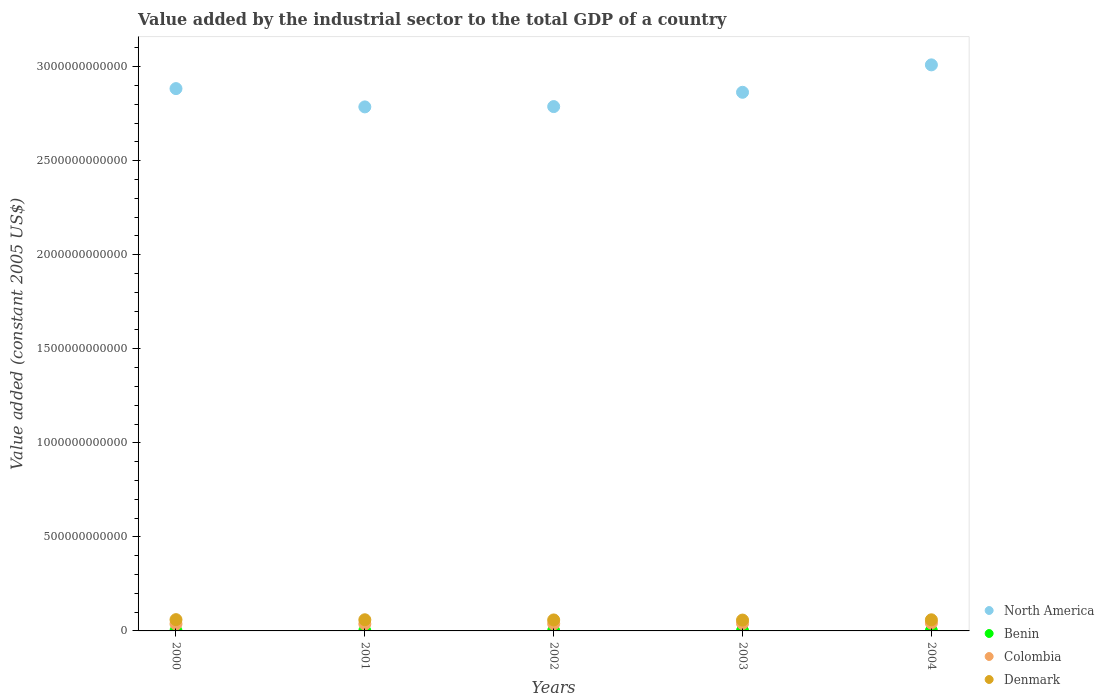How many different coloured dotlines are there?
Offer a very short reply. 4. Is the number of dotlines equal to the number of legend labels?
Offer a very short reply. Yes. What is the value added by the industrial sector in Colombia in 2002?
Keep it short and to the point. 3.79e+1. Across all years, what is the maximum value added by the industrial sector in Colombia?
Make the answer very short. 4.20e+1. Across all years, what is the minimum value added by the industrial sector in Colombia?
Make the answer very short. 3.68e+1. In which year was the value added by the industrial sector in Colombia maximum?
Provide a short and direct response. 2004. In which year was the value added by the industrial sector in Colombia minimum?
Your answer should be very brief. 2000. What is the total value added by the industrial sector in Colombia in the graph?
Provide a succinct answer. 1.93e+11. What is the difference between the value added by the industrial sector in Denmark in 2000 and that in 2002?
Offer a terse response. 1.55e+09. What is the difference between the value added by the industrial sector in North America in 2002 and the value added by the industrial sector in Denmark in 2003?
Make the answer very short. 2.73e+12. What is the average value added by the industrial sector in North America per year?
Provide a short and direct response. 2.87e+12. In the year 2002, what is the difference between the value added by the industrial sector in North America and value added by the industrial sector in Colombia?
Offer a terse response. 2.75e+12. In how many years, is the value added by the industrial sector in Denmark greater than 1900000000000 US$?
Keep it short and to the point. 0. What is the ratio of the value added by the industrial sector in North America in 2000 to that in 2001?
Offer a very short reply. 1.03. Is the difference between the value added by the industrial sector in North America in 2000 and 2004 greater than the difference between the value added by the industrial sector in Colombia in 2000 and 2004?
Provide a short and direct response. No. What is the difference between the highest and the second highest value added by the industrial sector in Colombia?
Provide a short and direct response. 2.31e+09. What is the difference between the highest and the lowest value added by the industrial sector in Colombia?
Your answer should be very brief. 5.16e+09. In how many years, is the value added by the industrial sector in Colombia greater than the average value added by the industrial sector in Colombia taken over all years?
Your response must be concise. 2. Is it the case that in every year, the sum of the value added by the industrial sector in North America and value added by the industrial sector in Denmark  is greater than the sum of value added by the industrial sector in Colombia and value added by the industrial sector in Benin?
Your answer should be compact. Yes. Is it the case that in every year, the sum of the value added by the industrial sector in Denmark and value added by the industrial sector in North America  is greater than the value added by the industrial sector in Benin?
Your answer should be compact. Yes. How many years are there in the graph?
Give a very brief answer. 5. What is the difference between two consecutive major ticks on the Y-axis?
Give a very brief answer. 5.00e+11. Where does the legend appear in the graph?
Offer a terse response. Bottom right. How many legend labels are there?
Offer a very short reply. 4. What is the title of the graph?
Offer a terse response. Value added by the industrial sector to the total GDP of a country. What is the label or title of the X-axis?
Your answer should be very brief. Years. What is the label or title of the Y-axis?
Your answer should be very brief. Value added (constant 2005 US$). What is the Value added (constant 2005 US$) in North America in 2000?
Offer a terse response. 2.88e+12. What is the Value added (constant 2005 US$) of Benin in 2000?
Your answer should be very brief. 1.16e+09. What is the Value added (constant 2005 US$) of Colombia in 2000?
Provide a succinct answer. 3.68e+1. What is the Value added (constant 2005 US$) of Denmark in 2000?
Ensure brevity in your answer.  5.99e+1. What is the Value added (constant 2005 US$) of North America in 2001?
Keep it short and to the point. 2.79e+12. What is the Value added (constant 2005 US$) of Benin in 2001?
Ensure brevity in your answer.  1.24e+09. What is the Value added (constant 2005 US$) in Colombia in 2001?
Your response must be concise. 3.69e+1. What is the Value added (constant 2005 US$) in Denmark in 2001?
Provide a succinct answer. 5.93e+1. What is the Value added (constant 2005 US$) of North America in 2002?
Offer a terse response. 2.79e+12. What is the Value added (constant 2005 US$) of Benin in 2002?
Keep it short and to the point. 1.25e+09. What is the Value added (constant 2005 US$) of Colombia in 2002?
Your response must be concise. 3.79e+1. What is the Value added (constant 2005 US$) of Denmark in 2002?
Make the answer very short. 5.84e+1. What is the Value added (constant 2005 US$) in North America in 2003?
Your answer should be compact. 2.86e+12. What is the Value added (constant 2005 US$) of Benin in 2003?
Offer a terse response. 1.25e+09. What is the Value added (constant 2005 US$) in Colombia in 2003?
Your response must be concise. 3.97e+1. What is the Value added (constant 2005 US$) in Denmark in 2003?
Offer a terse response. 5.77e+1. What is the Value added (constant 2005 US$) in North America in 2004?
Offer a very short reply. 3.01e+12. What is the Value added (constant 2005 US$) of Benin in 2004?
Ensure brevity in your answer.  1.27e+09. What is the Value added (constant 2005 US$) of Colombia in 2004?
Provide a succinct answer. 4.20e+1. What is the Value added (constant 2005 US$) in Denmark in 2004?
Offer a terse response. 5.91e+1. Across all years, what is the maximum Value added (constant 2005 US$) in North America?
Provide a succinct answer. 3.01e+12. Across all years, what is the maximum Value added (constant 2005 US$) of Benin?
Offer a terse response. 1.27e+09. Across all years, what is the maximum Value added (constant 2005 US$) of Colombia?
Your answer should be very brief. 4.20e+1. Across all years, what is the maximum Value added (constant 2005 US$) in Denmark?
Provide a short and direct response. 5.99e+1. Across all years, what is the minimum Value added (constant 2005 US$) of North America?
Provide a short and direct response. 2.79e+12. Across all years, what is the minimum Value added (constant 2005 US$) of Benin?
Your answer should be very brief. 1.16e+09. Across all years, what is the minimum Value added (constant 2005 US$) of Colombia?
Offer a very short reply. 3.68e+1. Across all years, what is the minimum Value added (constant 2005 US$) in Denmark?
Ensure brevity in your answer.  5.77e+1. What is the total Value added (constant 2005 US$) of North America in the graph?
Your answer should be very brief. 1.43e+13. What is the total Value added (constant 2005 US$) of Benin in the graph?
Your answer should be very brief. 6.17e+09. What is the total Value added (constant 2005 US$) in Colombia in the graph?
Provide a succinct answer. 1.93e+11. What is the total Value added (constant 2005 US$) in Denmark in the graph?
Offer a very short reply. 2.94e+11. What is the difference between the Value added (constant 2005 US$) of North America in 2000 and that in 2001?
Offer a very short reply. 9.72e+1. What is the difference between the Value added (constant 2005 US$) of Benin in 2000 and that in 2001?
Your response must be concise. -7.88e+07. What is the difference between the Value added (constant 2005 US$) in Colombia in 2000 and that in 2001?
Provide a succinct answer. -1.35e+08. What is the difference between the Value added (constant 2005 US$) in Denmark in 2000 and that in 2001?
Ensure brevity in your answer.  6.13e+08. What is the difference between the Value added (constant 2005 US$) of North America in 2000 and that in 2002?
Ensure brevity in your answer.  9.56e+1. What is the difference between the Value added (constant 2005 US$) in Benin in 2000 and that in 2002?
Give a very brief answer. -8.92e+07. What is the difference between the Value added (constant 2005 US$) in Colombia in 2000 and that in 2002?
Offer a terse response. -1.08e+09. What is the difference between the Value added (constant 2005 US$) of Denmark in 2000 and that in 2002?
Provide a short and direct response. 1.55e+09. What is the difference between the Value added (constant 2005 US$) in North America in 2000 and that in 2003?
Provide a short and direct response. 1.95e+1. What is the difference between the Value added (constant 2005 US$) in Benin in 2000 and that in 2003?
Keep it short and to the point. -8.47e+07. What is the difference between the Value added (constant 2005 US$) in Colombia in 2000 and that in 2003?
Make the answer very short. -2.86e+09. What is the difference between the Value added (constant 2005 US$) in Denmark in 2000 and that in 2003?
Your answer should be very brief. 2.24e+09. What is the difference between the Value added (constant 2005 US$) of North America in 2000 and that in 2004?
Your answer should be very brief. -1.26e+11. What is the difference between the Value added (constant 2005 US$) in Benin in 2000 and that in 2004?
Provide a short and direct response. -1.03e+08. What is the difference between the Value added (constant 2005 US$) of Colombia in 2000 and that in 2004?
Make the answer very short. -5.16e+09. What is the difference between the Value added (constant 2005 US$) of Denmark in 2000 and that in 2004?
Provide a short and direct response. 8.18e+08. What is the difference between the Value added (constant 2005 US$) in North America in 2001 and that in 2002?
Offer a terse response. -1.61e+09. What is the difference between the Value added (constant 2005 US$) in Benin in 2001 and that in 2002?
Offer a very short reply. -1.04e+07. What is the difference between the Value added (constant 2005 US$) of Colombia in 2001 and that in 2002?
Give a very brief answer. -9.49e+08. What is the difference between the Value added (constant 2005 US$) of Denmark in 2001 and that in 2002?
Provide a short and direct response. 9.36e+08. What is the difference between the Value added (constant 2005 US$) of North America in 2001 and that in 2003?
Ensure brevity in your answer.  -7.77e+1. What is the difference between the Value added (constant 2005 US$) of Benin in 2001 and that in 2003?
Ensure brevity in your answer.  -5.88e+06. What is the difference between the Value added (constant 2005 US$) in Colombia in 2001 and that in 2003?
Give a very brief answer. -2.72e+09. What is the difference between the Value added (constant 2005 US$) in Denmark in 2001 and that in 2003?
Make the answer very short. 1.63e+09. What is the difference between the Value added (constant 2005 US$) in North America in 2001 and that in 2004?
Make the answer very short. -2.23e+11. What is the difference between the Value added (constant 2005 US$) of Benin in 2001 and that in 2004?
Provide a short and direct response. -2.47e+07. What is the difference between the Value added (constant 2005 US$) of Colombia in 2001 and that in 2004?
Keep it short and to the point. -5.03e+09. What is the difference between the Value added (constant 2005 US$) in Denmark in 2001 and that in 2004?
Give a very brief answer. 2.05e+08. What is the difference between the Value added (constant 2005 US$) of North America in 2002 and that in 2003?
Your answer should be very brief. -7.61e+1. What is the difference between the Value added (constant 2005 US$) in Benin in 2002 and that in 2003?
Offer a terse response. 4.56e+06. What is the difference between the Value added (constant 2005 US$) of Colombia in 2002 and that in 2003?
Give a very brief answer. -1.77e+09. What is the difference between the Value added (constant 2005 US$) of Denmark in 2002 and that in 2003?
Your answer should be compact. 6.90e+08. What is the difference between the Value added (constant 2005 US$) in North America in 2002 and that in 2004?
Provide a short and direct response. -2.22e+11. What is the difference between the Value added (constant 2005 US$) of Benin in 2002 and that in 2004?
Your response must be concise. -1.42e+07. What is the difference between the Value added (constant 2005 US$) in Colombia in 2002 and that in 2004?
Your answer should be compact. -4.08e+09. What is the difference between the Value added (constant 2005 US$) in Denmark in 2002 and that in 2004?
Provide a succinct answer. -7.31e+08. What is the difference between the Value added (constant 2005 US$) in North America in 2003 and that in 2004?
Your response must be concise. -1.46e+11. What is the difference between the Value added (constant 2005 US$) in Benin in 2003 and that in 2004?
Make the answer very short. -1.88e+07. What is the difference between the Value added (constant 2005 US$) of Colombia in 2003 and that in 2004?
Provide a short and direct response. -2.31e+09. What is the difference between the Value added (constant 2005 US$) of Denmark in 2003 and that in 2004?
Your answer should be very brief. -1.42e+09. What is the difference between the Value added (constant 2005 US$) in North America in 2000 and the Value added (constant 2005 US$) in Benin in 2001?
Offer a very short reply. 2.88e+12. What is the difference between the Value added (constant 2005 US$) of North America in 2000 and the Value added (constant 2005 US$) of Colombia in 2001?
Keep it short and to the point. 2.85e+12. What is the difference between the Value added (constant 2005 US$) of North America in 2000 and the Value added (constant 2005 US$) of Denmark in 2001?
Your response must be concise. 2.82e+12. What is the difference between the Value added (constant 2005 US$) of Benin in 2000 and the Value added (constant 2005 US$) of Colombia in 2001?
Offer a terse response. -3.58e+1. What is the difference between the Value added (constant 2005 US$) in Benin in 2000 and the Value added (constant 2005 US$) in Denmark in 2001?
Your answer should be compact. -5.81e+1. What is the difference between the Value added (constant 2005 US$) of Colombia in 2000 and the Value added (constant 2005 US$) of Denmark in 2001?
Keep it short and to the point. -2.25e+1. What is the difference between the Value added (constant 2005 US$) of North America in 2000 and the Value added (constant 2005 US$) of Benin in 2002?
Provide a succinct answer. 2.88e+12. What is the difference between the Value added (constant 2005 US$) in North America in 2000 and the Value added (constant 2005 US$) in Colombia in 2002?
Offer a very short reply. 2.85e+12. What is the difference between the Value added (constant 2005 US$) in North America in 2000 and the Value added (constant 2005 US$) in Denmark in 2002?
Your answer should be very brief. 2.82e+12. What is the difference between the Value added (constant 2005 US$) in Benin in 2000 and the Value added (constant 2005 US$) in Colombia in 2002?
Offer a terse response. -3.67e+1. What is the difference between the Value added (constant 2005 US$) in Benin in 2000 and the Value added (constant 2005 US$) in Denmark in 2002?
Offer a very short reply. -5.72e+1. What is the difference between the Value added (constant 2005 US$) of Colombia in 2000 and the Value added (constant 2005 US$) of Denmark in 2002?
Your answer should be compact. -2.16e+1. What is the difference between the Value added (constant 2005 US$) of North America in 2000 and the Value added (constant 2005 US$) of Benin in 2003?
Ensure brevity in your answer.  2.88e+12. What is the difference between the Value added (constant 2005 US$) in North America in 2000 and the Value added (constant 2005 US$) in Colombia in 2003?
Offer a terse response. 2.84e+12. What is the difference between the Value added (constant 2005 US$) in North America in 2000 and the Value added (constant 2005 US$) in Denmark in 2003?
Make the answer very short. 2.83e+12. What is the difference between the Value added (constant 2005 US$) of Benin in 2000 and the Value added (constant 2005 US$) of Colombia in 2003?
Offer a very short reply. -3.85e+1. What is the difference between the Value added (constant 2005 US$) in Benin in 2000 and the Value added (constant 2005 US$) in Denmark in 2003?
Offer a very short reply. -5.65e+1. What is the difference between the Value added (constant 2005 US$) of Colombia in 2000 and the Value added (constant 2005 US$) of Denmark in 2003?
Your answer should be very brief. -2.09e+1. What is the difference between the Value added (constant 2005 US$) in North America in 2000 and the Value added (constant 2005 US$) in Benin in 2004?
Provide a succinct answer. 2.88e+12. What is the difference between the Value added (constant 2005 US$) in North America in 2000 and the Value added (constant 2005 US$) in Colombia in 2004?
Offer a terse response. 2.84e+12. What is the difference between the Value added (constant 2005 US$) of North America in 2000 and the Value added (constant 2005 US$) of Denmark in 2004?
Ensure brevity in your answer.  2.82e+12. What is the difference between the Value added (constant 2005 US$) of Benin in 2000 and the Value added (constant 2005 US$) of Colombia in 2004?
Offer a terse response. -4.08e+1. What is the difference between the Value added (constant 2005 US$) of Benin in 2000 and the Value added (constant 2005 US$) of Denmark in 2004?
Ensure brevity in your answer.  -5.79e+1. What is the difference between the Value added (constant 2005 US$) of Colombia in 2000 and the Value added (constant 2005 US$) of Denmark in 2004?
Keep it short and to the point. -2.23e+1. What is the difference between the Value added (constant 2005 US$) in North America in 2001 and the Value added (constant 2005 US$) in Benin in 2002?
Give a very brief answer. 2.78e+12. What is the difference between the Value added (constant 2005 US$) of North America in 2001 and the Value added (constant 2005 US$) of Colombia in 2002?
Offer a terse response. 2.75e+12. What is the difference between the Value added (constant 2005 US$) of North America in 2001 and the Value added (constant 2005 US$) of Denmark in 2002?
Your answer should be very brief. 2.73e+12. What is the difference between the Value added (constant 2005 US$) in Benin in 2001 and the Value added (constant 2005 US$) in Colombia in 2002?
Provide a short and direct response. -3.67e+1. What is the difference between the Value added (constant 2005 US$) in Benin in 2001 and the Value added (constant 2005 US$) in Denmark in 2002?
Provide a succinct answer. -5.71e+1. What is the difference between the Value added (constant 2005 US$) in Colombia in 2001 and the Value added (constant 2005 US$) in Denmark in 2002?
Provide a short and direct response. -2.14e+1. What is the difference between the Value added (constant 2005 US$) of North America in 2001 and the Value added (constant 2005 US$) of Benin in 2003?
Offer a terse response. 2.78e+12. What is the difference between the Value added (constant 2005 US$) of North America in 2001 and the Value added (constant 2005 US$) of Colombia in 2003?
Provide a succinct answer. 2.75e+12. What is the difference between the Value added (constant 2005 US$) in North America in 2001 and the Value added (constant 2005 US$) in Denmark in 2003?
Offer a terse response. 2.73e+12. What is the difference between the Value added (constant 2005 US$) in Benin in 2001 and the Value added (constant 2005 US$) in Colombia in 2003?
Keep it short and to the point. -3.84e+1. What is the difference between the Value added (constant 2005 US$) in Benin in 2001 and the Value added (constant 2005 US$) in Denmark in 2003?
Your answer should be very brief. -5.64e+1. What is the difference between the Value added (constant 2005 US$) of Colombia in 2001 and the Value added (constant 2005 US$) of Denmark in 2003?
Your response must be concise. -2.07e+1. What is the difference between the Value added (constant 2005 US$) in North America in 2001 and the Value added (constant 2005 US$) in Benin in 2004?
Ensure brevity in your answer.  2.78e+12. What is the difference between the Value added (constant 2005 US$) of North America in 2001 and the Value added (constant 2005 US$) of Colombia in 2004?
Offer a very short reply. 2.74e+12. What is the difference between the Value added (constant 2005 US$) in North America in 2001 and the Value added (constant 2005 US$) in Denmark in 2004?
Provide a short and direct response. 2.73e+12. What is the difference between the Value added (constant 2005 US$) in Benin in 2001 and the Value added (constant 2005 US$) in Colombia in 2004?
Ensure brevity in your answer.  -4.07e+1. What is the difference between the Value added (constant 2005 US$) of Benin in 2001 and the Value added (constant 2005 US$) of Denmark in 2004?
Your answer should be compact. -5.79e+1. What is the difference between the Value added (constant 2005 US$) of Colombia in 2001 and the Value added (constant 2005 US$) of Denmark in 2004?
Ensure brevity in your answer.  -2.22e+1. What is the difference between the Value added (constant 2005 US$) in North America in 2002 and the Value added (constant 2005 US$) in Benin in 2003?
Your answer should be compact. 2.79e+12. What is the difference between the Value added (constant 2005 US$) of North America in 2002 and the Value added (constant 2005 US$) of Colombia in 2003?
Provide a short and direct response. 2.75e+12. What is the difference between the Value added (constant 2005 US$) of North America in 2002 and the Value added (constant 2005 US$) of Denmark in 2003?
Keep it short and to the point. 2.73e+12. What is the difference between the Value added (constant 2005 US$) of Benin in 2002 and the Value added (constant 2005 US$) of Colombia in 2003?
Provide a short and direct response. -3.84e+1. What is the difference between the Value added (constant 2005 US$) in Benin in 2002 and the Value added (constant 2005 US$) in Denmark in 2003?
Keep it short and to the point. -5.64e+1. What is the difference between the Value added (constant 2005 US$) in Colombia in 2002 and the Value added (constant 2005 US$) in Denmark in 2003?
Offer a very short reply. -1.98e+1. What is the difference between the Value added (constant 2005 US$) in North America in 2002 and the Value added (constant 2005 US$) in Benin in 2004?
Provide a succinct answer. 2.79e+12. What is the difference between the Value added (constant 2005 US$) in North America in 2002 and the Value added (constant 2005 US$) in Colombia in 2004?
Offer a very short reply. 2.75e+12. What is the difference between the Value added (constant 2005 US$) in North America in 2002 and the Value added (constant 2005 US$) in Denmark in 2004?
Ensure brevity in your answer.  2.73e+12. What is the difference between the Value added (constant 2005 US$) of Benin in 2002 and the Value added (constant 2005 US$) of Colombia in 2004?
Ensure brevity in your answer.  -4.07e+1. What is the difference between the Value added (constant 2005 US$) of Benin in 2002 and the Value added (constant 2005 US$) of Denmark in 2004?
Offer a terse response. -5.78e+1. What is the difference between the Value added (constant 2005 US$) of Colombia in 2002 and the Value added (constant 2005 US$) of Denmark in 2004?
Ensure brevity in your answer.  -2.12e+1. What is the difference between the Value added (constant 2005 US$) of North America in 2003 and the Value added (constant 2005 US$) of Benin in 2004?
Keep it short and to the point. 2.86e+12. What is the difference between the Value added (constant 2005 US$) of North America in 2003 and the Value added (constant 2005 US$) of Colombia in 2004?
Your answer should be very brief. 2.82e+12. What is the difference between the Value added (constant 2005 US$) in North America in 2003 and the Value added (constant 2005 US$) in Denmark in 2004?
Provide a short and direct response. 2.80e+12. What is the difference between the Value added (constant 2005 US$) in Benin in 2003 and the Value added (constant 2005 US$) in Colombia in 2004?
Offer a very short reply. -4.07e+1. What is the difference between the Value added (constant 2005 US$) of Benin in 2003 and the Value added (constant 2005 US$) of Denmark in 2004?
Offer a terse response. -5.79e+1. What is the difference between the Value added (constant 2005 US$) of Colombia in 2003 and the Value added (constant 2005 US$) of Denmark in 2004?
Your answer should be very brief. -1.94e+1. What is the average Value added (constant 2005 US$) in North America per year?
Give a very brief answer. 2.87e+12. What is the average Value added (constant 2005 US$) of Benin per year?
Provide a succinct answer. 1.23e+09. What is the average Value added (constant 2005 US$) of Colombia per year?
Offer a terse response. 3.87e+1. What is the average Value added (constant 2005 US$) in Denmark per year?
Your answer should be very brief. 5.89e+1. In the year 2000, what is the difference between the Value added (constant 2005 US$) in North America and Value added (constant 2005 US$) in Benin?
Make the answer very short. 2.88e+12. In the year 2000, what is the difference between the Value added (constant 2005 US$) in North America and Value added (constant 2005 US$) in Colombia?
Your answer should be compact. 2.85e+12. In the year 2000, what is the difference between the Value added (constant 2005 US$) in North America and Value added (constant 2005 US$) in Denmark?
Make the answer very short. 2.82e+12. In the year 2000, what is the difference between the Value added (constant 2005 US$) in Benin and Value added (constant 2005 US$) in Colombia?
Make the answer very short. -3.56e+1. In the year 2000, what is the difference between the Value added (constant 2005 US$) in Benin and Value added (constant 2005 US$) in Denmark?
Your response must be concise. -5.88e+1. In the year 2000, what is the difference between the Value added (constant 2005 US$) of Colombia and Value added (constant 2005 US$) of Denmark?
Keep it short and to the point. -2.31e+1. In the year 2001, what is the difference between the Value added (constant 2005 US$) in North America and Value added (constant 2005 US$) in Benin?
Your answer should be compact. 2.78e+12. In the year 2001, what is the difference between the Value added (constant 2005 US$) in North America and Value added (constant 2005 US$) in Colombia?
Keep it short and to the point. 2.75e+12. In the year 2001, what is the difference between the Value added (constant 2005 US$) in North America and Value added (constant 2005 US$) in Denmark?
Your answer should be very brief. 2.73e+12. In the year 2001, what is the difference between the Value added (constant 2005 US$) in Benin and Value added (constant 2005 US$) in Colombia?
Ensure brevity in your answer.  -3.57e+1. In the year 2001, what is the difference between the Value added (constant 2005 US$) in Benin and Value added (constant 2005 US$) in Denmark?
Your answer should be very brief. -5.81e+1. In the year 2001, what is the difference between the Value added (constant 2005 US$) in Colombia and Value added (constant 2005 US$) in Denmark?
Your answer should be compact. -2.24e+1. In the year 2002, what is the difference between the Value added (constant 2005 US$) in North America and Value added (constant 2005 US$) in Benin?
Your answer should be very brief. 2.79e+12. In the year 2002, what is the difference between the Value added (constant 2005 US$) in North America and Value added (constant 2005 US$) in Colombia?
Provide a short and direct response. 2.75e+12. In the year 2002, what is the difference between the Value added (constant 2005 US$) of North America and Value added (constant 2005 US$) of Denmark?
Offer a terse response. 2.73e+12. In the year 2002, what is the difference between the Value added (constant 2005 US$) in Benin and Value added (constant 2005 US$) in Colombia?
Make the answer very short. -3.66e+1. In the year 2002, what is the difference between the Value added (constant 2005 US$) in Benin and Value added (constant 2005 US$) in Denmark?
Your answer should be compact. -5.71e+1. In the year 2002, what is the difference between the Value added (constant 2005 US$) in Colombia and Value added (constant 2005 US$) in Denmark?
Your response must be concise. -2.05e+1. In the year 2003, what is the difference between the Value added (constant 2005 US$) of North America and Value added (constant 2005 US$) of Benin?
Provide a succinct answer. 2.86e+12. In the year 2003, what is the difference between the Value added (constant 2005 US$) of North America and Value added (constant 2005 US$) of Colombia?
Your answer should be compact. 2.82e+12. In the year 2003, what is the difference between the Value added (constant 2005 US$) in North America and Value added (constant 2005 US$) in Denmark?
Your answer should be very brief. 2.81e+12. In the year 2003, what is the difference between the Value added (constant 2005 US$) of Benin and Value added (constant 2005 US$) of Colombia?
Provide a short and direct response. -3.84e+1. In the year 2003, what is the difference between the Value added (constant 2005 US$) in Benin and Value added (constant 2005 US$) in Denmark?
Offer a terse response. -5.64e+1. In the year 2003, what is the difference between the Value added (constant 2005 US$) in Colombia and Value added (constant 2005 US$) in Denmark?
Ensure brevity in your answer.  -1.80e+1. In the year 2004, what is the difference between the Value added (constant 2005 US$) of North America and Value added (constant 2005 US$) of Benin?
Your answer should be compact. 3.01e+12. In the year 2004, what is the difference between the Value added (constant 2005 US$) in North America and Value added (constant 2005 US$) in Colombia?
Keep it short and to the point. 2.97e+12. In the year 2004, what is the difference between the Value added (constant 2005 US$) of North America and Value added (constant 2005 US$) of Denmark?
Offer a very short reply. 2.95e+12. In the year 2004, what is the difference between the Value added (constant 2005 US$) of Benin and Value added (constant 2005 US$) of Colombia?
Keep it short and to the point. -4.07e+1. In the year 2004, what is the difference between the Value added (constant 2005 US$) in Benin and Value added (constant 2005 US$) in Denmark?
Keep it short and to the point. -5.78e+1. In the year 2004, what is the difference between the Value added (constant 2005 US$) of Colombia and Value added (constant 2005 US$) of Denmark?
Provide a short and direct response. -1.71e+1. What is the ratio of the Value added (constant 2005 US$) of North America in 2000 to that in 2001?
Make the answer very short. 1.03. What is the ratio of the Value added (constant 2005 US$) of Benin in 2000 to that in 2001?
Offer a very short reply. 0.94. What is the ratio of the Value added (constant 2005 US$) in Colombia in 2000 to that in 2001?
Give a very brief answer. 1. What is the ratio of the Value added (constant 2005 US$) in Denmark in 2000 to that in 2001?
Keep it short and to the point. 1.01. What is the ratio of the Value added (constant 2005 US$) in North America in 2000 to that in 2002?
Provide a short and direct response. 1.03. What is the ratio of the Value added (constant 2005 US$) in Benin in 2000 to that in 2002?
Offer a very short reply. 0.93. What is the ratio of the Value added (constant 2005 US$) of Colombia in 2000 to that in 2002?
Offer a terse response. 0.97. What is the ratio of the Value added (constant 2005 US$) in Denmark in 2000 to that in 2002?
Keep it short and to the point. 1.03. What is the ratio of the Value added (constant 2005 US$) of North America in 2000 to that in 2003?
Provide a succinct answer. 1.01. What is the ratio of the Value added (constant 2005 US$) in Benin in 2000 to that in 2003?
Offer a terse response. 0.93. What is the ratio of the Value added (constant 2005 US$) of Colombia in 2000 to that in 2003?
Your response must be concise. 0.93. What is the ratio of the Value added (constant 2005 US$) of Denmark in 2000 to that in 2003?
Your answer should be very brief. 1.04. What is the ratio of the Value added (constant 2005 US$) of North America in 2000 to that in 2004?
Provide a succinct answer. 0.96. What is the ratio of the Value added (constant 2005 US$) in Benin in 2000 to that in 2004?
Provide a short and direct response. 0.92. What is the ratio of the Value added (constant 2005 US$) of Colombia in 2000 to that in 2004?
Ensure brevity in your answer.  0.88. What is the ratio of the Value added (constant 2005 US$) of Denmark in 2000 to that in 2004?
Your answer should be compact. 1.01. What is the ratio of the Value added (constant 2005 US$) of Denmark in 2001 to that in 2002?
Offer a very short reply. 1.02. What is the ratio of the Value added (constant 2005 US$) in North America in 2001 to that in 2003?
Give a very brief answer. 0.97. What is the ratio of the Value added (constant 2005 US$) in Benin in 2001 to that in 2003?
Your answer should be compact. 1. What is the ratio of the Value added (constant 2005 US$) of Colombia in 2001 to that in 2003?
Provide a short and direct response. 0.93. What is the ratio of the Value added (constant 2005 US$) of Denmark in 2001 to that in 2003?
Your response must be concise. 1.03. What is the ratio of the Value added (constant 2005 US$) of North America in 2001 to that in 2004?
Offer a very short reply. 0.93. What is the ratio of the Value added (constant 2005 US$) of Benin in 2001 to that in 2004?
Offer a terse response. 0.98. What is the ratio of the Value added (constant 2005 US$) in Colombia in 2001 to that in 2004?
Your answer should be very brief. 0.88. What is the ratio of the Value added (constant 2005 US$) in Denmark in 2001 to that in 2004?
Provide a succinct answer. 1. What is the ratio of the Value added (constant 2005 US$) in North America in 2002 to that in 2003?
Your answer should be very brief. 0.97. What is the ratio of the Value added (constant 2005 US$) in Benin in 2002 to that in 2003?
Offer a very short reply. 1. What is the ratio of the Value added (constant 2005 US$) in Colombia in 2002 to that in 2003?
Your answer should be very brief. 0.96. What is the ratio of the Value added (constant 2005 US$) of Denmark in 2002 to that in 2003?
Your response must be concise. 1.01. What is the ratio of the Value added (constant 2005 US$) of North America in 2002 to that in 2004?
Provide a succinct answer. 0.93. What is the ratio of the Value added (constant 2005 US$) of Benin in 2002 to that in 2004?
Offer a very short reply. 0.99. What is the ratio of the Value added (constant 2005 US$) of Colombia in 2002 to that in 2004?
Offer a very short reply. 0.9. What is the ratio of the Value added (constant 2005 US$) in Denmark in 2002 to that in 2004?
Make the answer very short. 0.99. What is the ratio of the Value added (constant 2005 US$) in North America in 2003 to that in 2004?
Your answer should be very brief. 0.95. What is the ratio of the Value added (constant 2005 US$) of Benin in 2003 to that in 2004?
Give a very brief answer. 0.99. What is the ratio of the Value added (constant 2005 US$) of Colombia in 2003 to that in 2004?
Ensure brevity in your answer.  0.94. What is the ratio of the Value added (constant 2005 US$) of Denmark in 2003 to that in 2004?
Provide a succinct answer. 0.98. What is the difference between the highest and the second highest Value added (constant 2005 US$) in North America?
Give a very brief answer. 1.26e+11. What is the difference between the highest and the second highest Value added (constant 2005 US$) of Benin?
Ensure brevity in your answer.  1.42e+07. What is the difference between the highest and the second highest Value added (constant 2005 US$) of Colombia?
Keep it short and to the point. 2.31e+09. What is the difference between the highest and the second highest Value added (constant 2005 US$) in Denmark?
Provide a succinct answer. 6.13e+08. What is the difference between the highest and the lowest Value added (constant 2005 US$) in North America?
Your response must be concise. 2.23e+11. What is the difference between the highest and the lowest Value added (constant 2005 US$) of Benin?
Offer a terse response. 1.03e+08. What is the difference between the highest and the lowest Value added (constant 2005 US$) in Colombia?
Keep it short and to the point. 5.16e+09. What is the difference between the highest and the lowest Value added (constant 2005 US$) in Denmark?
Provide a succinct answer. 2.24e+09. 